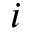Convert formula to latex. <formula><loc_0><loc_0><loc_500><loc_500>i</formula> 